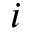Convert formula to latex. <formula><loc_0><loc_0><loc_500><loc_500>i</formula> 